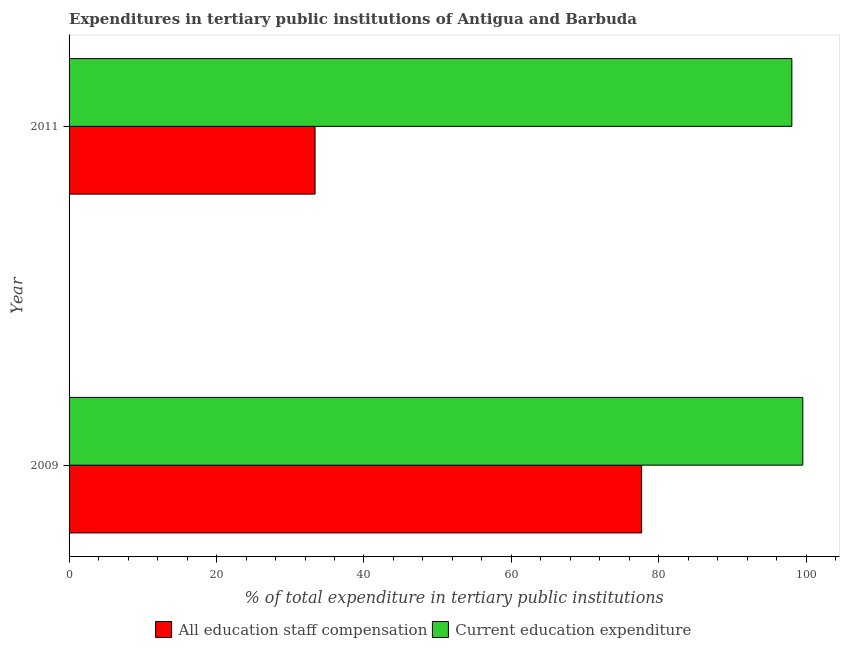Are the number of bars per tick equal to the number of legend labels?
Make the answer very short. Yes. Are the number of bars on each tick of the Y-axis equal?
Your answer should be very brief. Yes. What is the label of the 2nd group of bars from the top?
Keep it short and to the point. 2009. In how many cases, is the number of bars for a given year not equal to the number of legend labels?
Ensure brevity in your answer.  0. What is the expenditure in education in 2009?
Provide a short and direct response. 99.52. Across all years, what is the maximum expenditure in staff compensation?
Ensure brevity in your answer.  77.66. Across all years, what is the minimum expenditure in education?
Provide a succinct answer. 98.04. In which year was the expenditure in staff compensation maximum?
Keep it short and to the point. 2009. What is the total expenditure in education in the graph?
Offer a very short reply. 197.56. What is the difference between the expenditure in education in 2009 and that in 2011?
Ensure brevity in your answer.  1.48. What is the difference between the expenditure in education in 2011 and the expenditure in staff compensation in 2009?
Keep it short and to the point. 20.38. What is the average expenditure in staff compensation per year?
Provide a succinct answer. 55.51. In the year 2009, what is the difference between the expenditure in education and expenditure in staff compensation?
Give a very brief answer. 21.86. In how many years, is the expenditure in staff compensation greater than 4 %?
Offer a very short reply. 2. Is the expenditure in staff compensation in 2009 less than that in 2011?
Keep it short and to the point. No. Is the difference between the expenditure in education in 2009 and 2011 greater than the difference between the expenditure in staff compensation in 2009 and 2011?
Ensure brevity in your answer.  No. What does the 1st bar from the top in 2011 represents?
Give a very brief answer. Current education expenditure. What does the 1st bar from the bottom in 2011 represents?
Your response must be concise. All education staff compensation. How many bars are there?
Ensure brevity in your answer.  4. Does the graph contain grids?
Offer a very short reply. No. How many legend labels are there?
Keep it short and to the point. 2. How are the legend labels stacked?
Offer a terse response. Horizontal. What is the title of the graph?
Your response must be concise. Expenditures in tertiary public institutions of Antigua and Barbuda. Does "Gasoline" appear as one of the legend labels in the graph?
Provide a succinct answer. No. What is the label or title of the X-axis?
Your response must be concise. % of total expenditure in tertiary public institutions. What is the % of total expenditure in tertiary public institutions of All education staff compensation in 2009?
Your answer should be compact. 77.66. What is the % of total expenditure in tertiary public institutions of Current education expenditure in 2009?
Provide a succinct answer. 99.52. What is the % of total expenditure in tertiary public institutions of All education staff compensation in 2011?
Offer a very short reply. 33.36. What is the % of total expenditure in tertiary public institutions of Current education expenditure in 2011?
Ensure brevity in your answer.  98.04. Across all years, what is the maximum % of total expenditure in tertiary public institutions in All education staff compensation?
Offer a terse response. 77.66. Across all years, what is the maximum % of total expenditure in tertiary public institutions of Current education expenditure?
Provide a succinct answer. 99.52. Across all years, what is the minimum % of total expenditure in tertiary public institutions in All education staff compensation?
Give a very brief answer. 33.36. Across all years, what is the minimum % of total expenditure in tertiary public institutions of Current education expenditure?
Your answer should be compact. 98.04. What is the total % of total expenditure in tertiary public institutions of All education staff compensation in the graph?
Provide a succinct answer. 111.02. What is the total % of total expenditure in tertiary public institutions in Current education expenditure in the graph?
Your answer should be compact. 197.56. What is the difference between the % of total expenditure in tertiary public institutions of All education staff compensation in 2009 and that in 2011?
Your answer should be compact. 44.29. What is the difference between the % of total expenditure in tertiary public institutions of Current education expenditure in 2009 and that in 2011?
Your response must be concise. 1.48. What is the difference between the % of total expenditure in tertiary public institutions in All education staff compensation in 2009 and the % of total expenditure in tertiary public institutions in Current education expenditure in 2011?
Make the answer very short. -20.38. What is the average % of total expenditure in tertiary public institutions of All education staff compensation per year?
Give a very brief answer. 55.51. What is the average % of total expenditure in tertiary public institutions of Current education expenditure per year?
Offer a terse response. 98.78. In the year 2009, what is the difference between the % of total expenditure in tertiary public institutions of All education staff compensation and % of total expenditure in tertiary public institutions of Current education expenditure?
Provide a succinct answer. -21.87. In the year 2011, what is the difference between the % of total expenditure in tertiary public institutions of All education staff compensation and % of total expenditure in tertiary public institutions of Current education expenditure?
Provide a short and direct response. -64.67. What is the ratio of the % of total expenditure in tertiary public institutions of All education staff compensation in 2009 to that in 2011?
Your answer should be very brief. 2.33. What is the ratio of the % of total expenditure in tertiary public institutions in Current education expenditure in 2009 to that in 2011?
Give a very brief answer. 1.02. What is the difference between the highest and the second highest % of total expenditure in tertiary public institutions of All education staff compensation?
Your answer should be very brief. 44.29. What is the difference between the highest and the second highest % of total expenditure in tertiary public institutions of Current education expenditure?
Ensure brevity in your answer.  1.48. What is the difference between the highest and the lowest % of total expenditure in tertiary public institutions in All education staff compensation?
Your answer should be very brief. 44.29. What is the difference between the highest and the lowest % of total expenditure in tertiary public institutions in Current education expenditure?
Give a very brief answer. 1.48. 